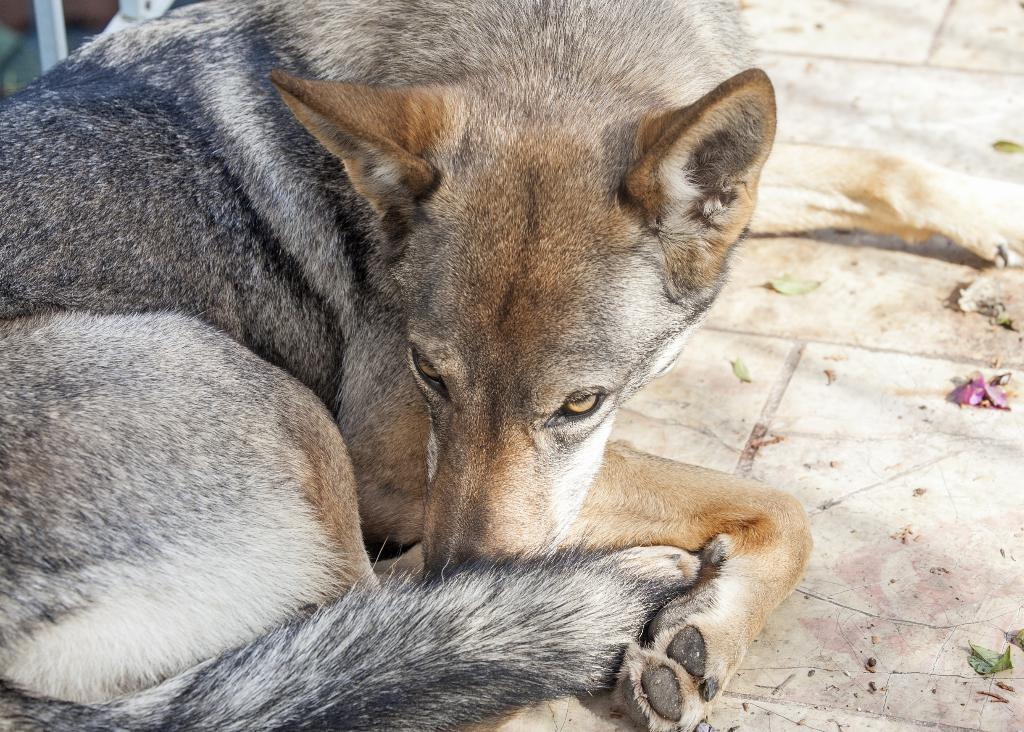What type of animal is in the image? There is a dog in the image. Where is the dog located in the image? The dog is sitting on the floor. What can be seen behind the dog in the image? There is an object behind the dog. What type of cook is depicted in the image? There is no cook depicted in the image; it features a dog sitting on the floor. How many men are present in the image? There is no mention of men in the image; it only features a dog sitting on the floor. 